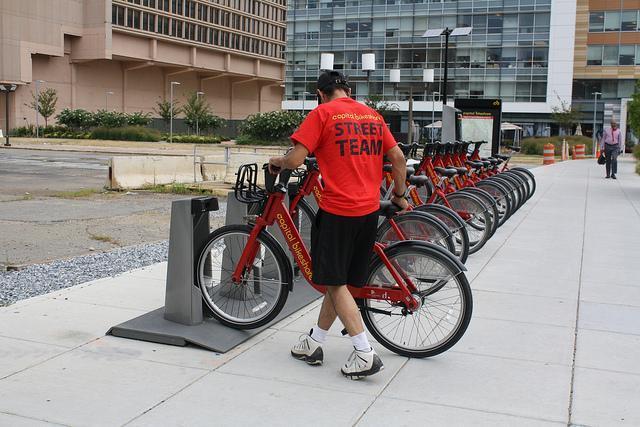How many bicycles are visible?
Give a very brief answer. 4. 